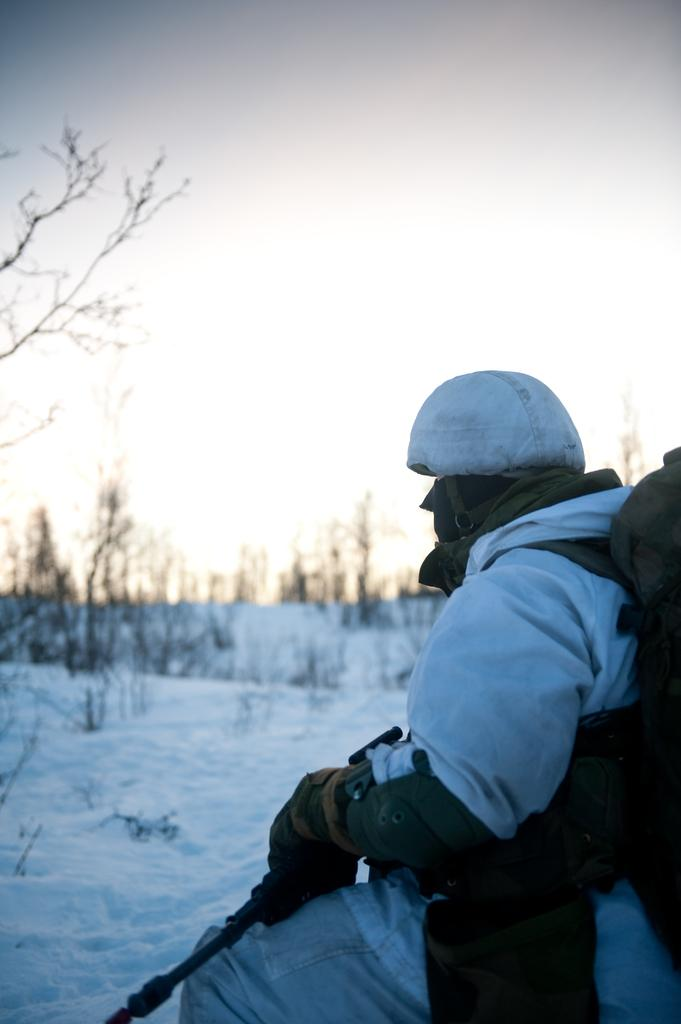Who or what is present in the image? There is a person in the image. What is the person wearing? The person is wearing a dress. What is the person holding in the image? The person is holding a stick. What is the weather like in the image? There is snow visible in the image, indicating a cold and snowy environment. What type of natural environment is depicted in the image? There are many trees in the image, suggesting a forest or wooded area. What can be seen in the background of the image? The sky is visible in the background. What type of wall can be seen in the image? There is no wall present in the image. 